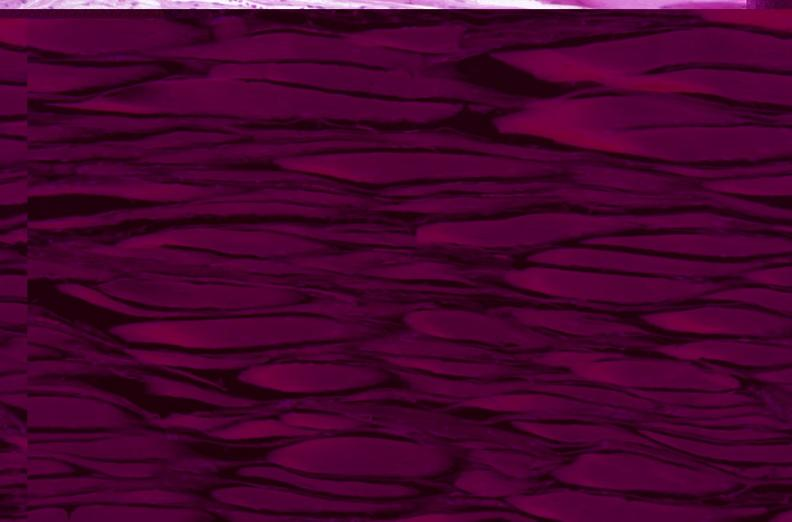what does this image show?
Answer the question using a single word or phrase. Skeletal muscle 